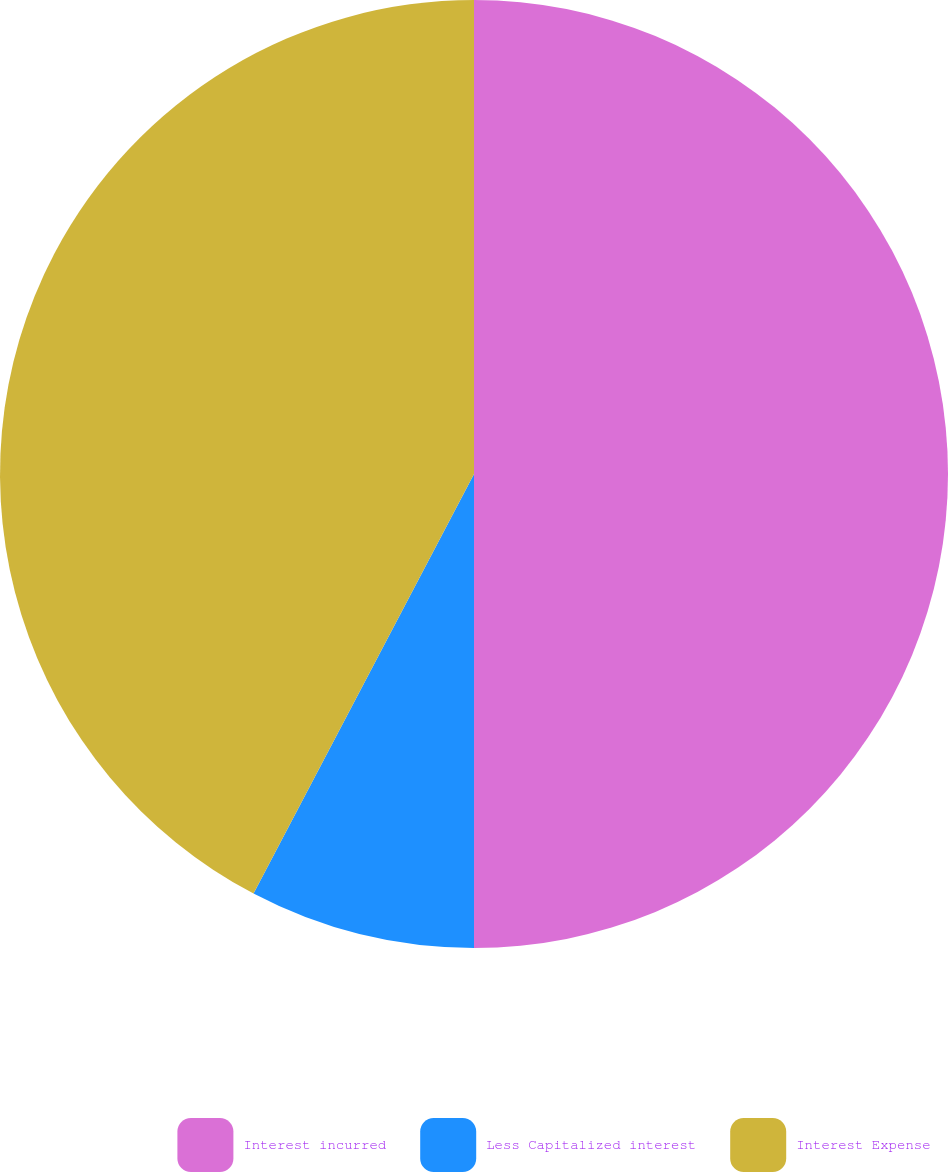Convert chart. <chart><loc_0><loc_0><loc_500><loc_500><pie_chart><fcel>Interest incurred<fcel>Less Capitalized interest<fcel>Interest Expense<nl><fcel>50.0%<fcel>7.7%<fcel>42.3%<nl></chart> 